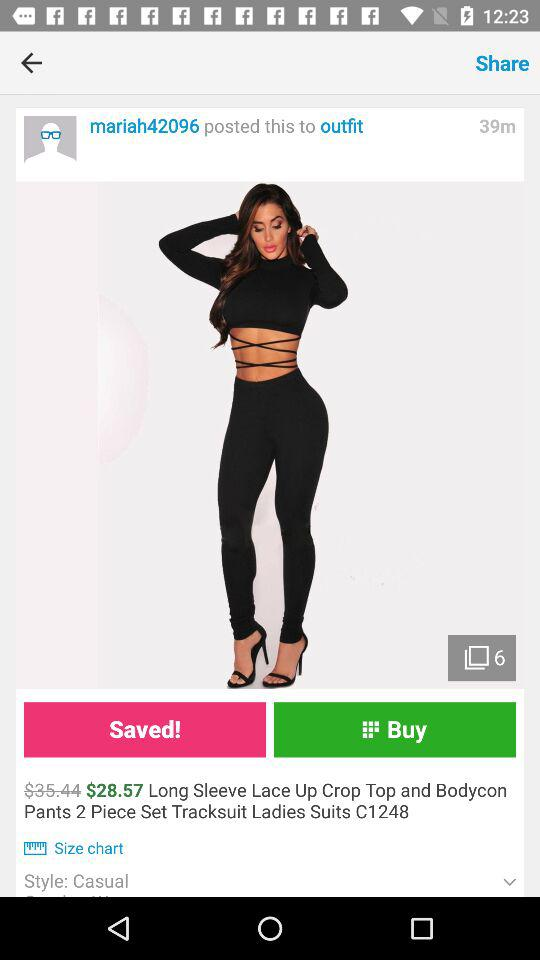What is the name of the application?
When the provided information is insufficient, respond with <no answer>. <no answer> 